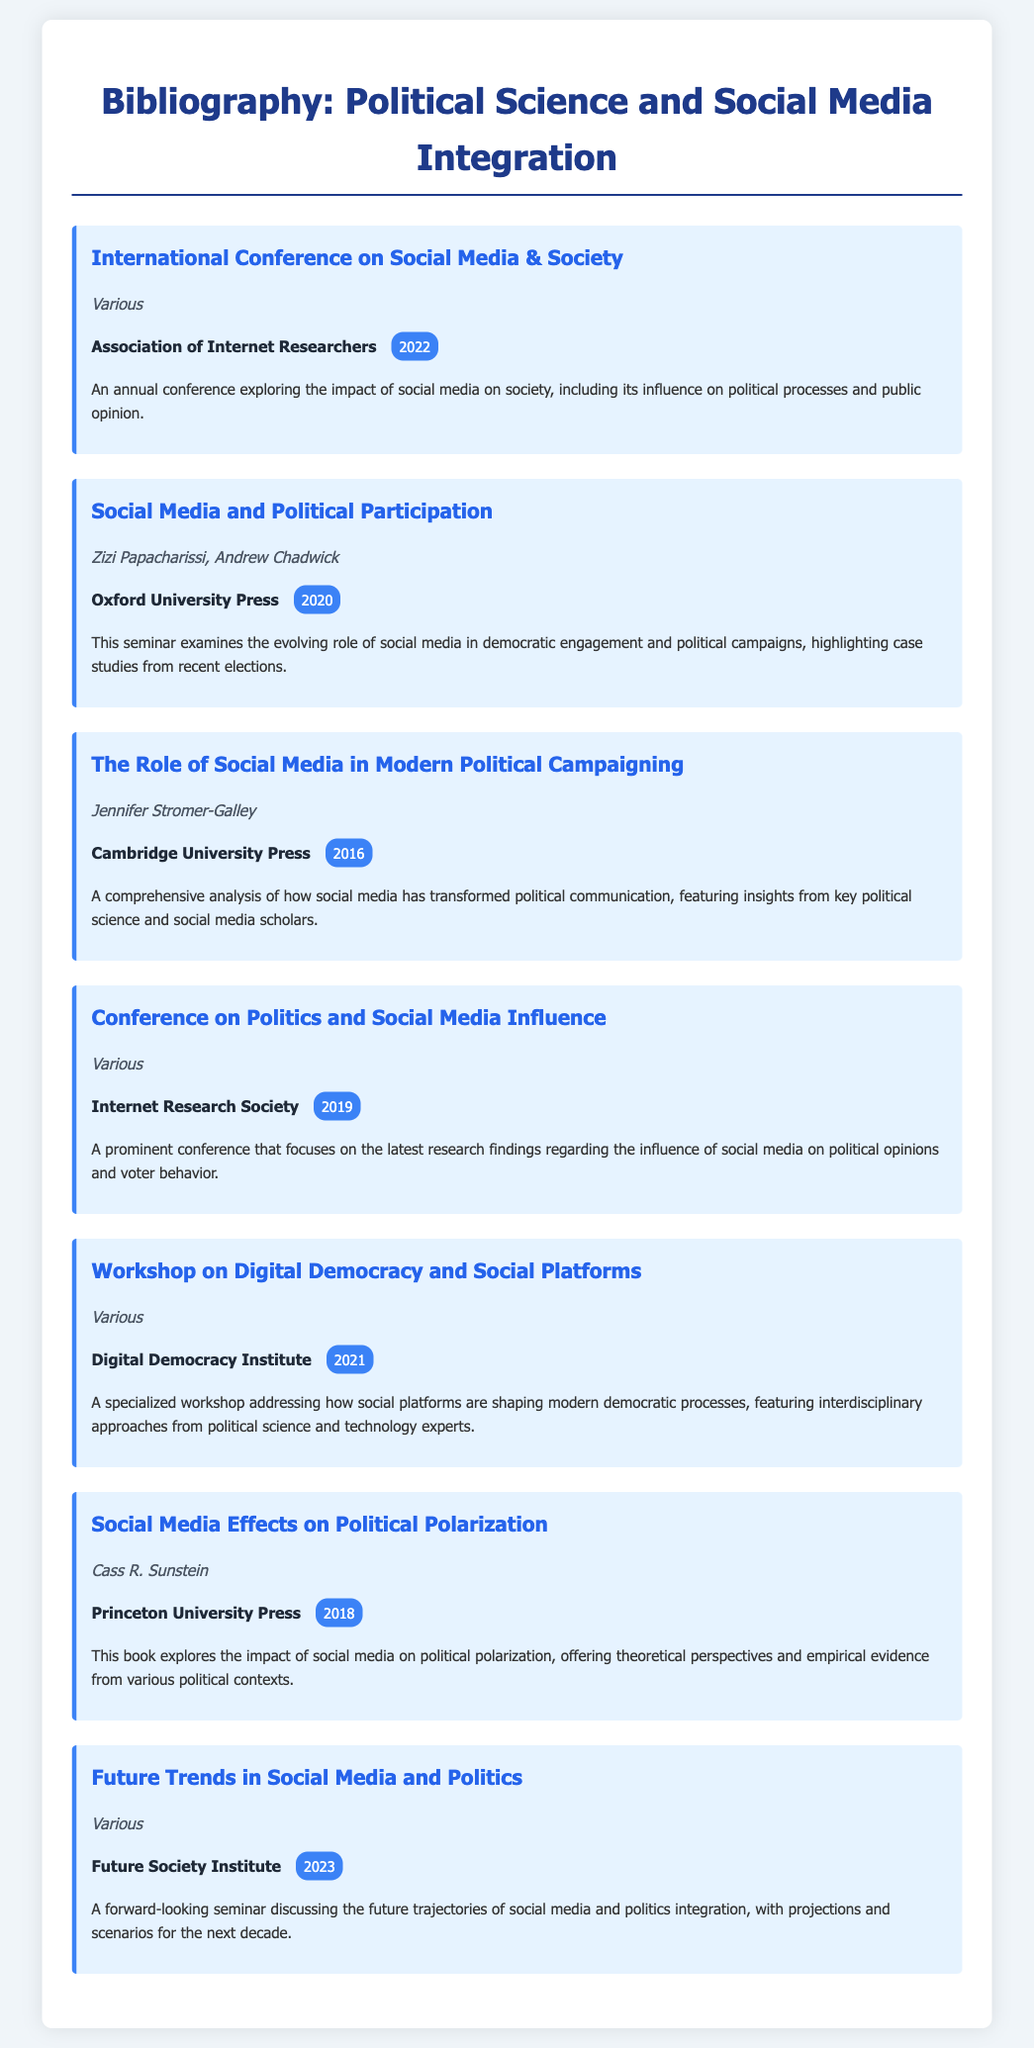what is the title of the conference organized by the Association of Internet Researchers? The title is mentioned in the entry as it is the first item listed in the bibliography.
Answer: International Conference on Social Media & Society who is one of the authors of the seminar "Social Media and Political Participation"? This question can be answered by identifying the authors listed in the corresponding entry.
Answer: Zizi Papacharissi what year was the workshop on digital democracy held? The year is provided in the bibliography entry, which includes the publication year of the event.
Answer: 2021 which publisher is associated with the book "Social Media Effects on Political Polarization"? This information can be located in the entry detailing the book's publication details.
Answer: Princeton University Press how many different entries list various authors? This requires counting the number of entries that specify "Various" authors in the bibliography.
Answer: 4 what is the primary focus of the "Future Trends in Social Media and Politics" seminar? This answer can be derived from the description provided in the bibliography entry.
Answer: Future trajectories of social media and politics integration who authored "The Role of Social Media in Modern Political Campaigning"? Identifying the individual author listed in the bibliography entry can answer this question directly.
Answer: Jennifer Stromer-Galley in which year did the conference on politics and social media influence take place? The year is explicitly mentioned in the entry for this specific conference.
Answer: 2019 